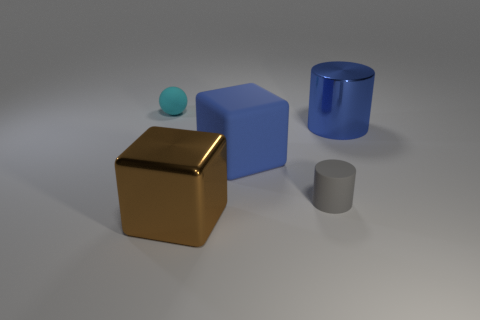What is the color of the small rubber object that is behind the cylinder that is behind the big blue cube?
Provide a succinct answer. Cyan. There is a gray thing that is the same shape as the blue shiny thing; what material is it?
Provide a short and direct response. Rubber. The cylinder in front of the large shiny object that is to the right of the shiny thing in front of the blue cylinder is what color?
Your response must be concise. Gray. What number of things are big brown things or large objects?
Provide a succinct answer. 3. What number of other large things are the same shape as the big blue rubber object?
Make the answer very short. 1. Is the material of the brown block the same as the big thing that is behind the rubber cube?
Give a very brief answer. Yes. There is a brown object that is made of the same material as the blue cylinder; what size is it?
Your answer should be compact. Large. There is a cube that is on the right side of the large brown shiny object; what size is it?
Your answer should be compact. Large. How many other blue shiny cylinders have the same size as the blue shiny cylinder?
Your answer should be very brief. 0. Is there a matte block of the same color as the big shiny cylinder?
Provide a succinct answer. Yes. 